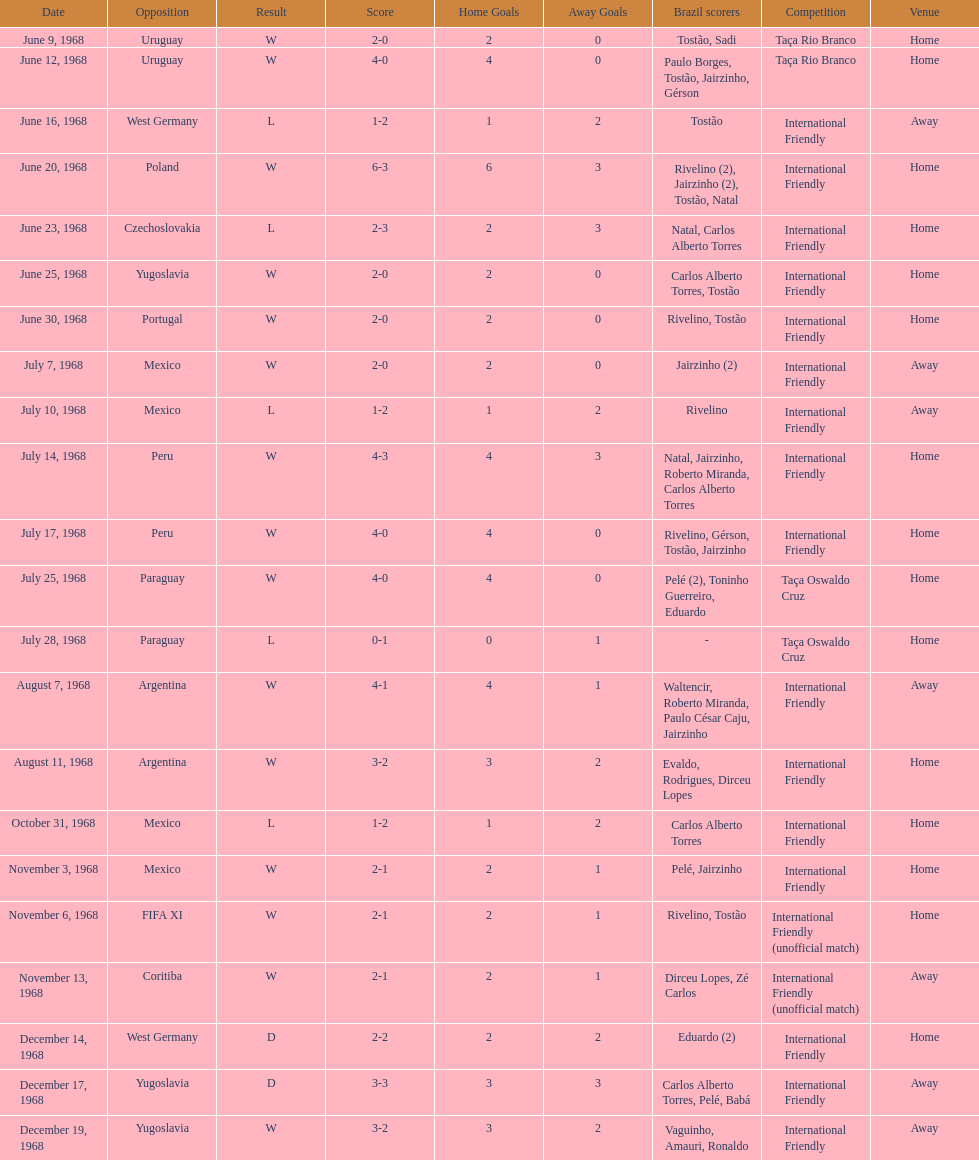How many games are victories? 15. 